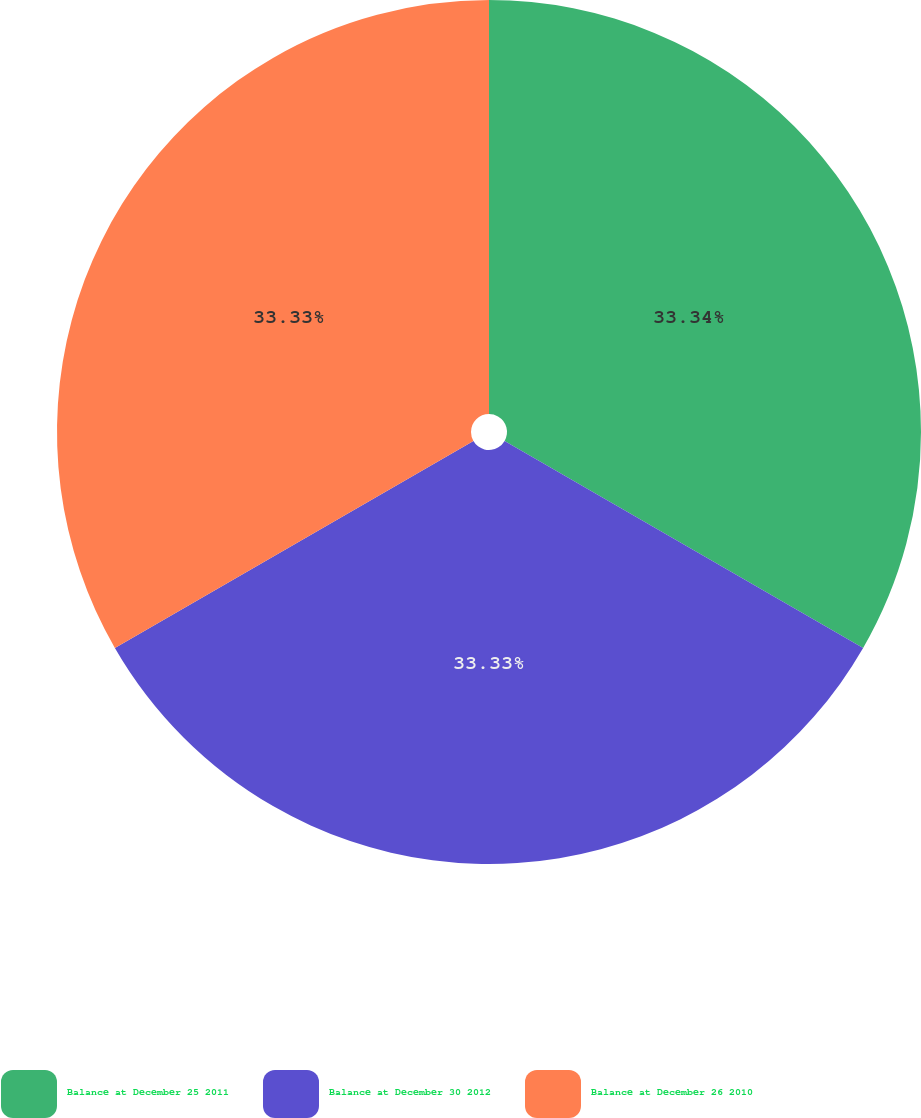Convert chart to OTSL. <chart><loc_0><loc_0><loc_500><loc_500><pie_chart><fcel>Balance at December 25 2011<fcel>Balance at December 30 2012<fcel>Balance at December 26 2010<nl><fcel>33.33%<fcel>33.33%<fcel>33.33%<nl></chart> 